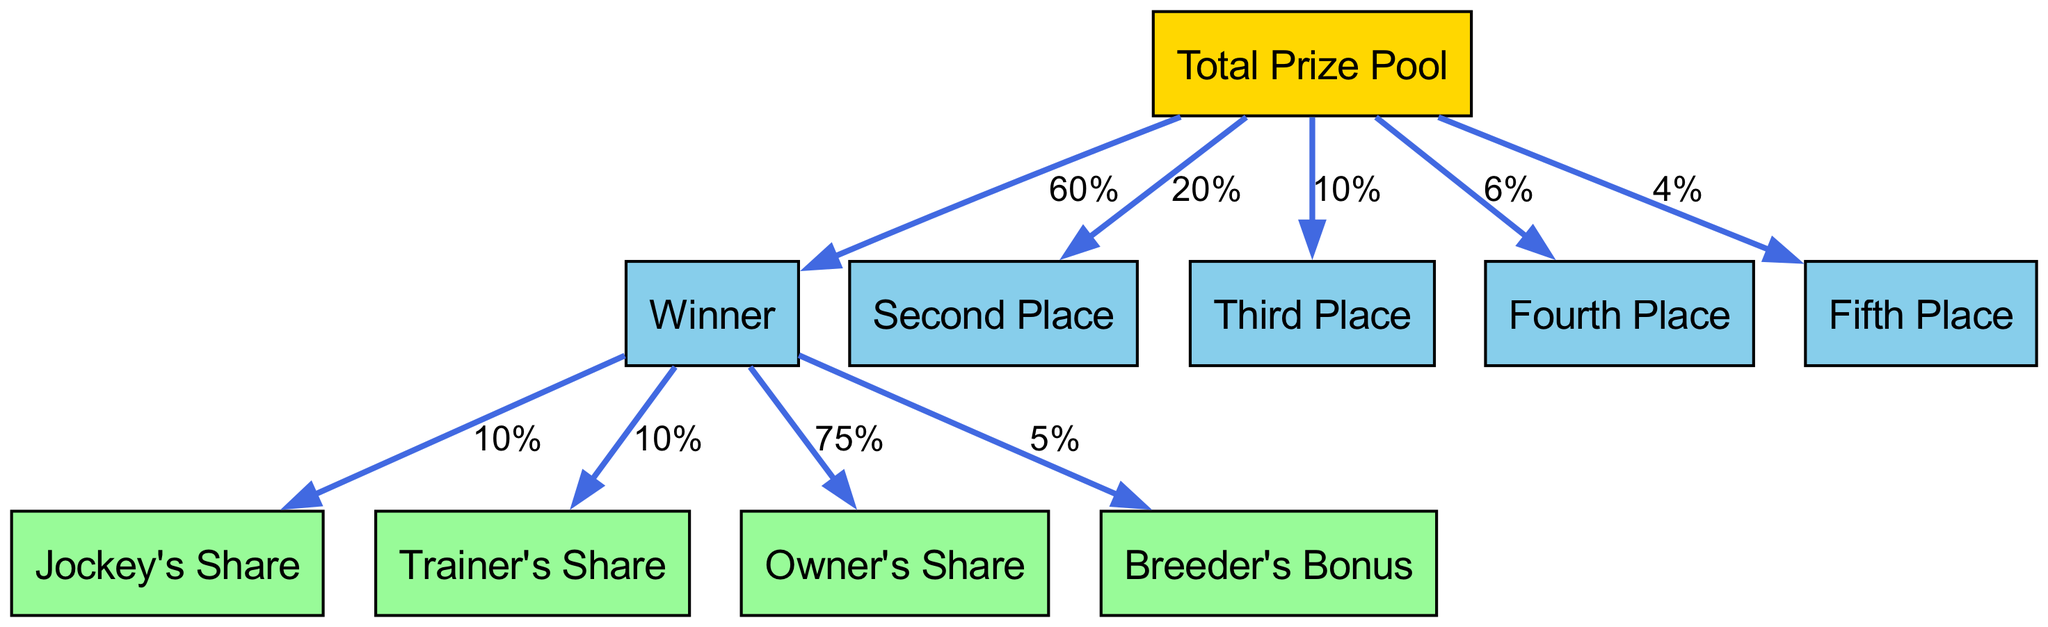What percentage of the total prize pool is awarded to the winner? The diagram indicates that the winner receives 60% of the total prize pool. This is explicitly stated as the percentage in the edge connecting "Total Prize Pool" to "Winner."
Answer: 60% What is the prize distribution for fifth place? According to the diagram, the fifth place receives 4% of the total prize pool. This percentage is shown as an edge from "Total Prize Pool" to "Fifth Place."
Answer: 4% Who receives the largest share from the winner's earnings? The diagram shows that the owner receives 75% from the winner's earnings, which is identified through the connections from "Winner" to "Owner's Share."
Answer: Owner's Share How many places receive a share from the total prize pool? The diagram lists five places that receive shares: Winner, Second Place, Third Place, Fourth Place, and Fifth Place. Thus, there are a total of five nodes connected from the "Total Prize Pool."
Answer: 5 What is the total percentage allocated to second and third places combined? The second place receives 20% and the third place receives 10%. When combined, this results in 30%. This is calculated by adding the percentages from the edges pointing to "Second Place" and "Third Place."
Answer: 30% If the total prize pool is $1,000,000, how much does the breeder receive? The breeder receives 5% of the winner's share. First, determine the winner's share, which is $600,000 (60% of $1,000,000). Then, calculate 5% of $600,000, resulting in $30,000. This involves combining the information about the winner's share and the breeder's percentage.
Answer: $30,000 What percentage of the winner's earnings does the jockey receive? The diagram specifies that the jockey receives 10% of the winner's earnings, as shown by the edge from "Winner" to "Jockey's Share."
Answer: 10% How many edges point from the total prize pool to the places? The diagram shows five edges pointing from "Total Prize Pool" to the places: Winner, Second Place, Third Place, Fourth Place, and Fifth Place. Counting these connections gives the answer.
Answer: 5 